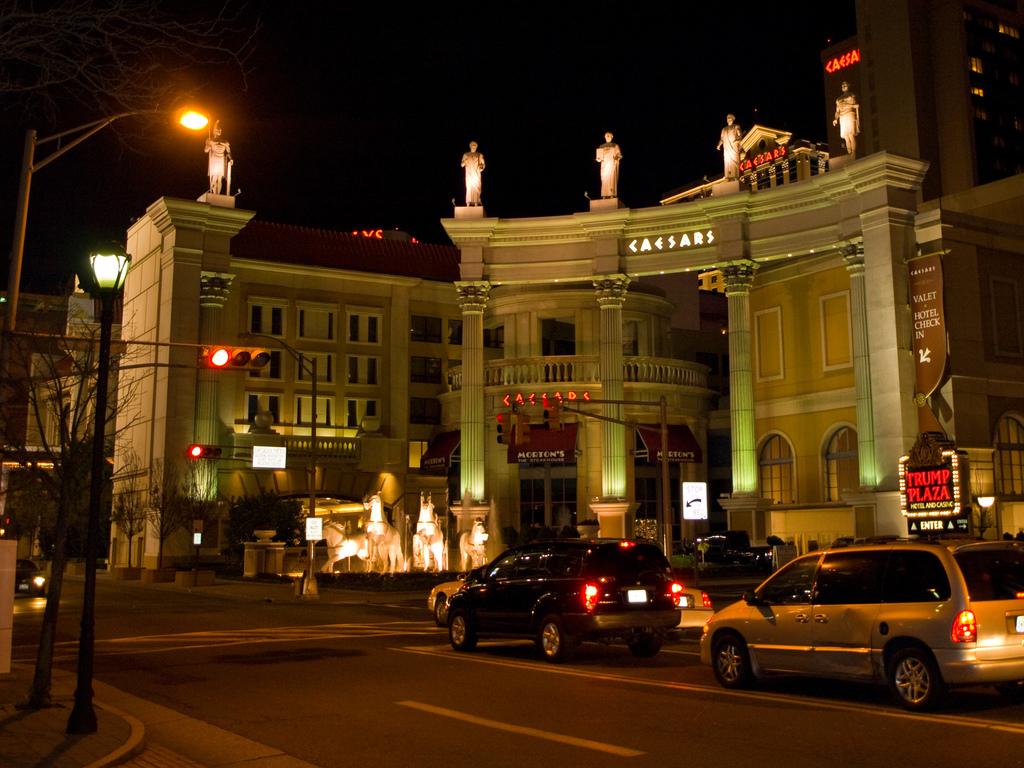What does it say in white towards the top of the building?
Give a very brief answer. Caesars. What does the red neon sign on the right say?
Make the answer very short. Trump plaza. 